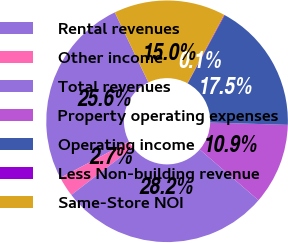Convert chart. <chart><loc_0><loc_0><loc_500><loc_500><pie_chart><fcel>Rental revenues<fcel>Other income<fcel>Total revenues<fcel>Property operating expenses<fcel>Operating income<fcel>Less Non-building revenue<fcel>Same-Store NOI<nl><fcel>25.64%<fcel>2.67%<fcel>28.22%<fcel>10.87%<fcel>17.55%<fcel>0.08%<fcel>14.97%<nl></chart> 